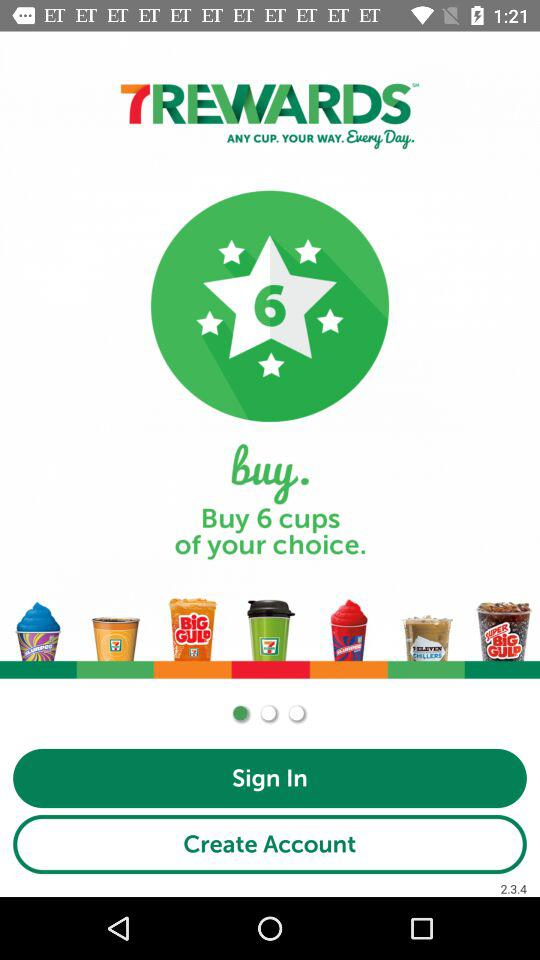How many cups of my preferred choice can I purchase? There are 6 cups. 